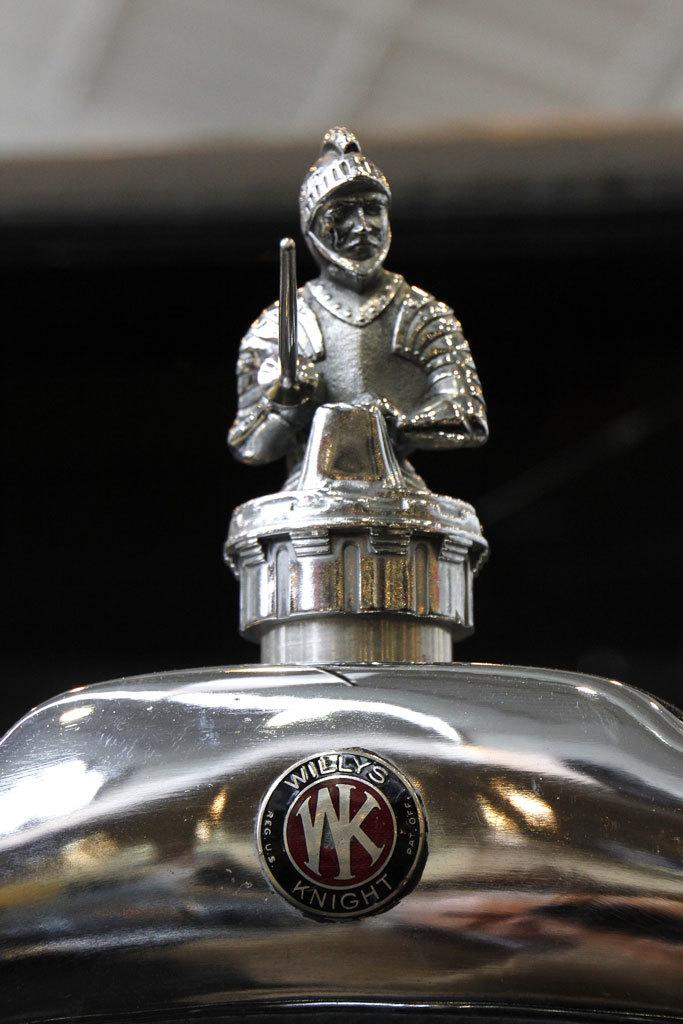What is the main subject of the image? The main subject of the image is a statue of a person. What is the person in the statue wearing? The person is wearing a helmet. What is the person in the statue holding? The person is holding something. Can you describe any additional features in the image? There is a logo in the front of the image. How many tomatoes are on the person's face in the image? There are no tomatoes present in the image, and the person's face is not visible. What type of attraction is depicted in the image? The image does not depict an attraction; it features a statue of a person with a helmet and an object. 